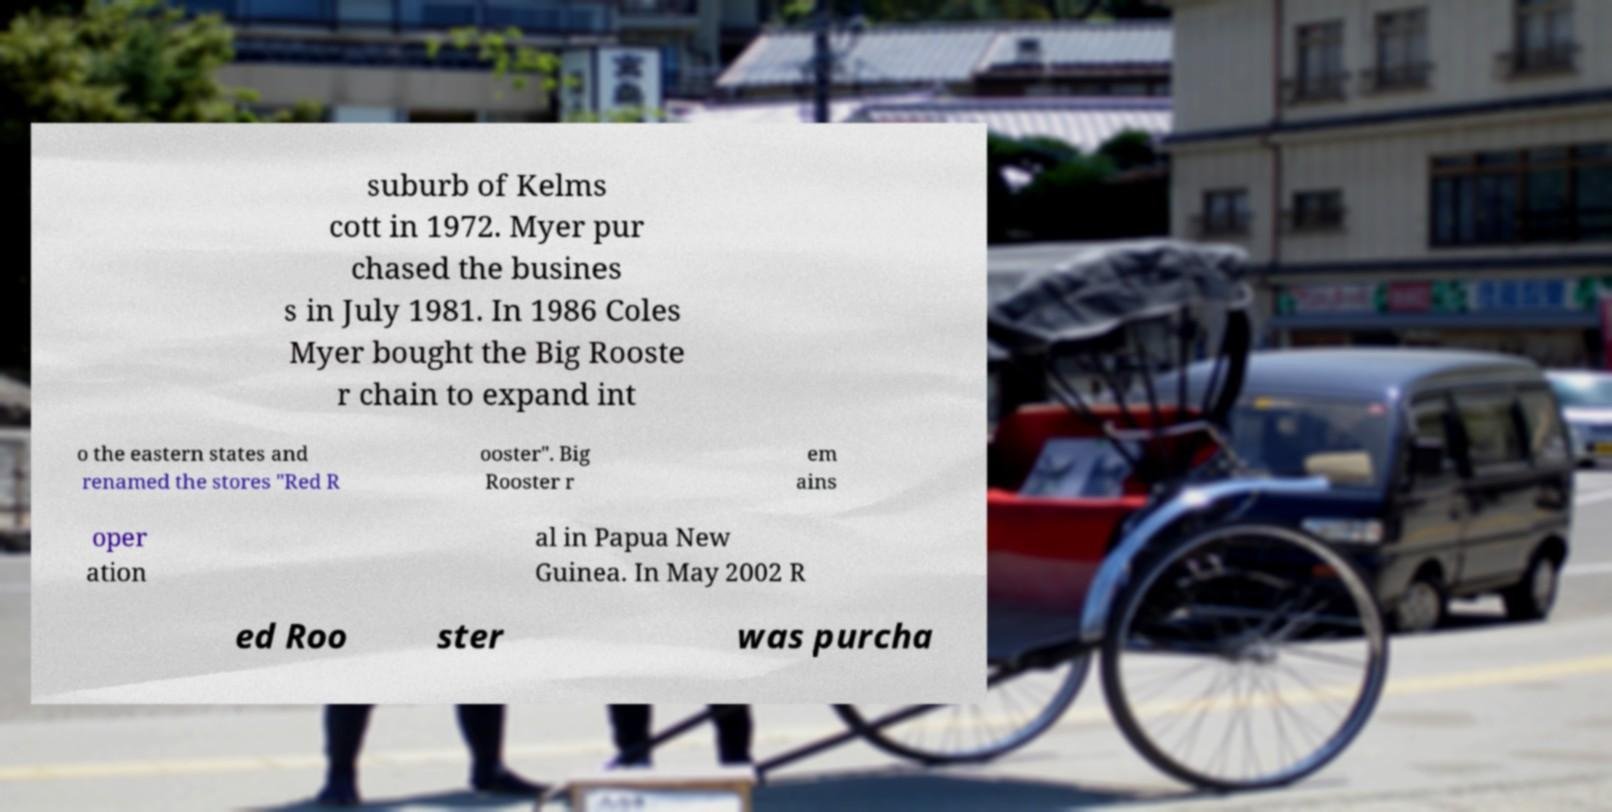Can you read and provide the text displayed in the image?This photo seems to have some interesting text. Can you extract and type it out for me? suburb of Kelms cott in 1972. Myer pur chased the busines s in July 1981. In 1986 Coles Myer bought the Big Rooste r chain to expand int o the eastern states and renamed the stores "Red R ooster". Big Rooster r em ains oper ation al in Papua New Guinea. In May 2002 R ed Roo ster was purcha 